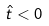<formula> <loc_0><loc_0><loc_500><loc_500>\hat { t } < 0</formula> 